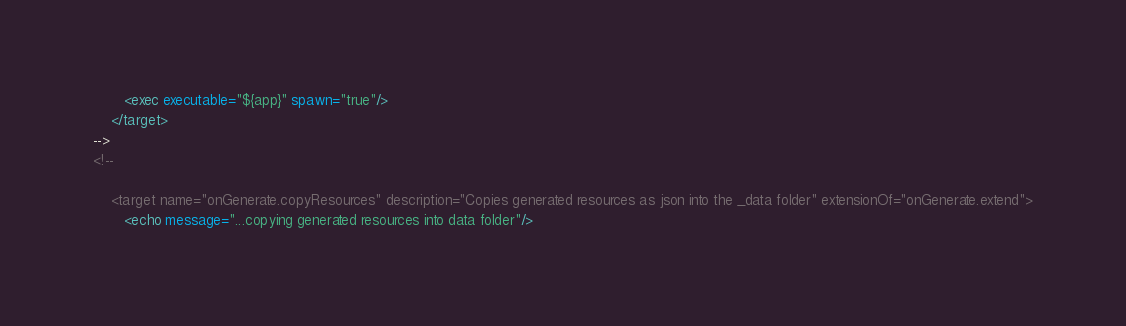Convert code to text. <code><loc_0><loc_0><loc_500><loc_500><_XML_>       <exec executable="${app}" spawn="true"/>
    </target>
-->
<!--

    <target name="onGenerate.copyResources" description="Copies generated resources as json into the _data folder" extensionOf="onGenerate.extend">
       <echo message="...copying generated resources into data folder"/></code> 